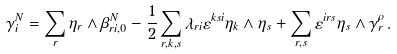Convert formula to latex. <formula><loc_0><loc_0><loc_500><loc_500>\gamma _ { i } ^ { N } = \sum _ { r } \eta _ { r } \wedge \beta _ { r i , 0 } ^ { N } - \frac { 1 } { 2 } \sum _ { r , k , s } \lambda _ { r i } \varepsilon ^ { k s i } \eta _ { k } \wedge \eta _ { s } + \sum _ { r , s } \varepsilon ^ { i r s } \eta _ { s } \wedge \gamma _ { r } ^ { \rho } \, .</formula> 